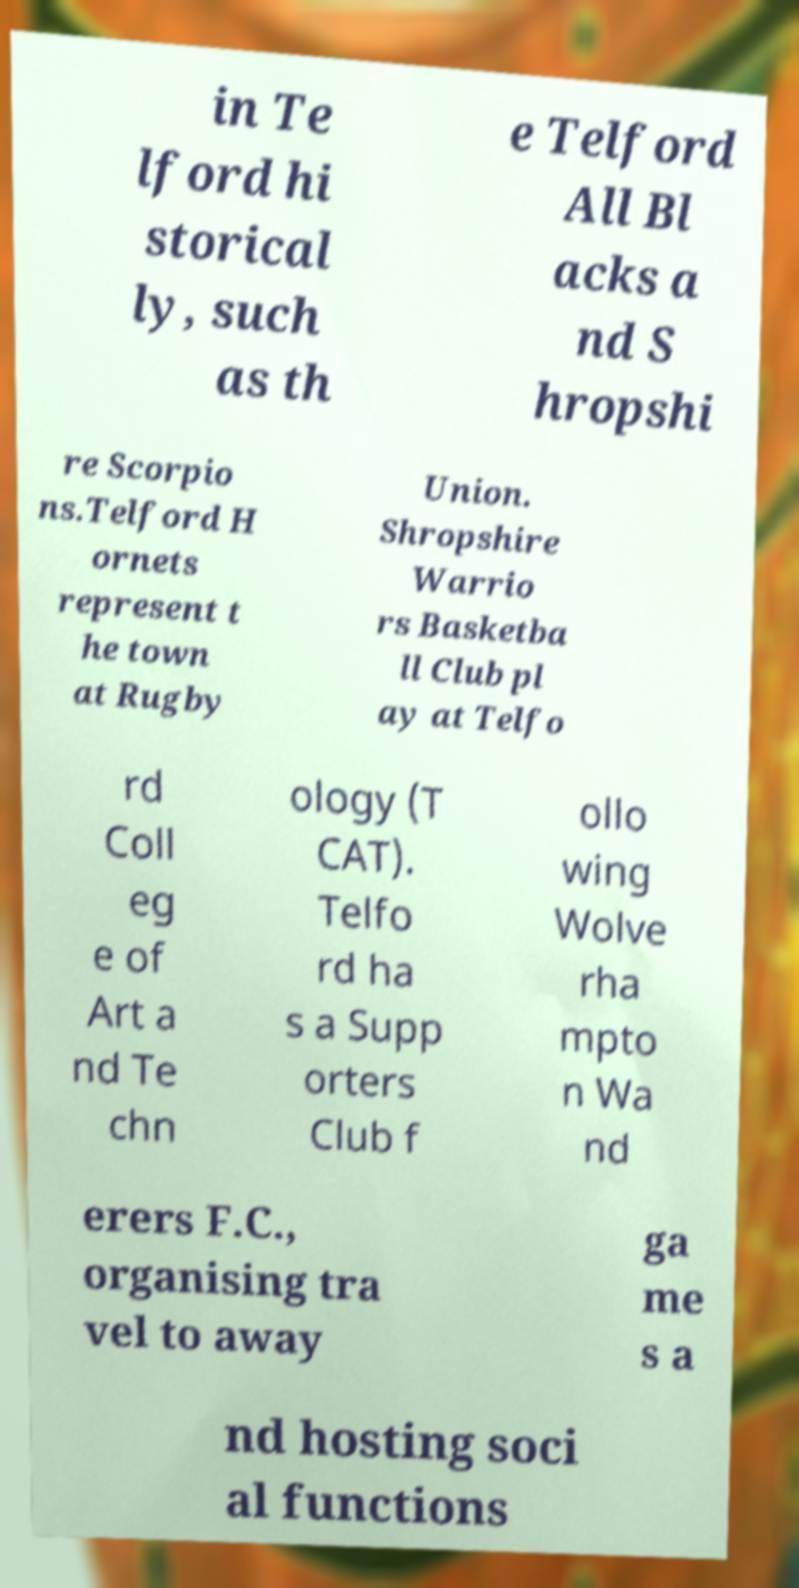I need the written content from this picture converted into text. Can you do that? in Te lford hi storical ly, such as th e Telford All Bl acks a nd S hropshi re Scorpio ns.Telford H ornets represent t he town at Rugby Union. Shropshire Warrio rs Basketba ll Club pl ay at Telfo rd Coll eg e of Art a nd Te chn ology (T CAT). Telfo rd ha s a Supp orters Club f ollo wing Wolve rha mpto n Wa nd erers F.C., organising tra vel to away ga me s a nd hosting soci al functions 